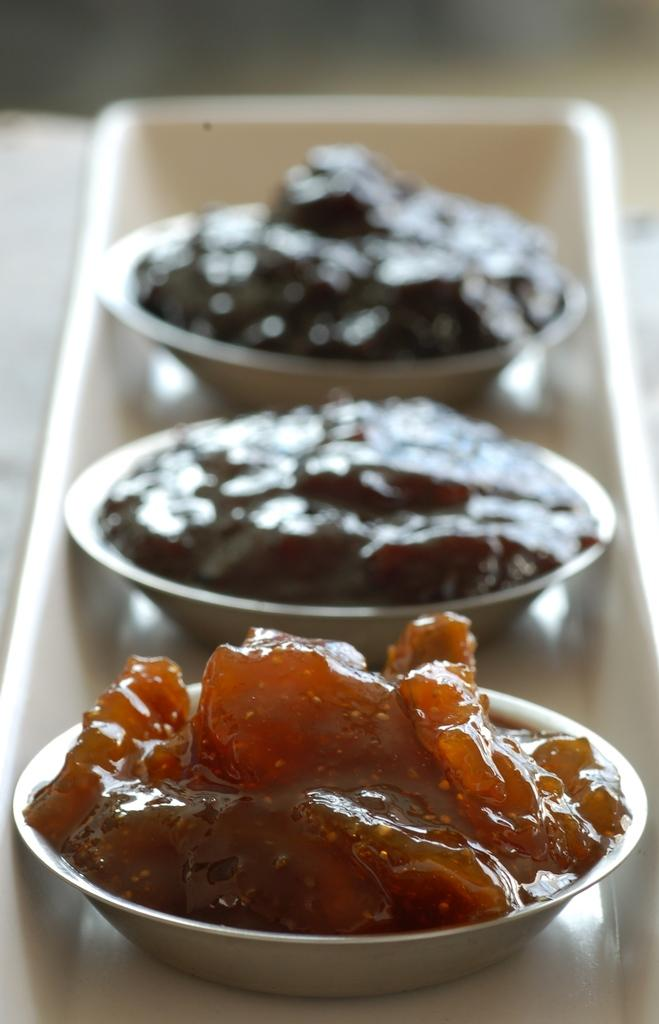What is present on the tray in the image? There is a tray in the image, and it contains three bowls. What is inside each of the bowls on the tray? Each bowl has food in it. Where are the bowls placed in the image? The bowls are placed on a surface. What type of wood is the brother using to crush the food in the image? There is no brother or wood present in the image, and the food is already in the bowls. 